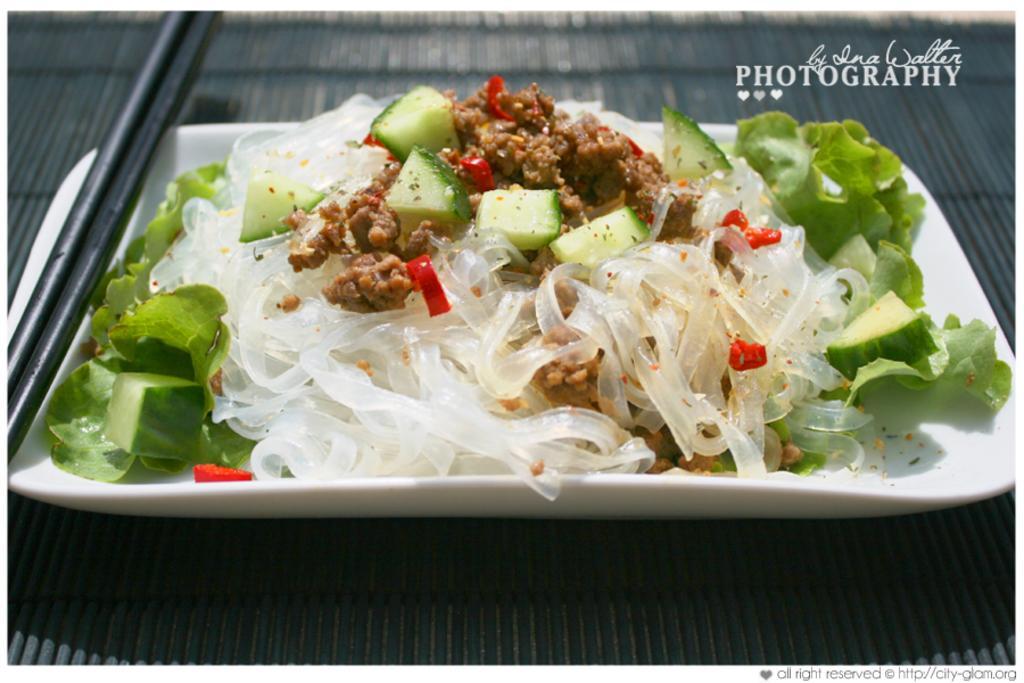Describe this image in one or two sentences. There are vegetable pieces, leaves and other food items on a white color tray which is on a surface. In the top right, there is a watermark. And the background is gray in color. 